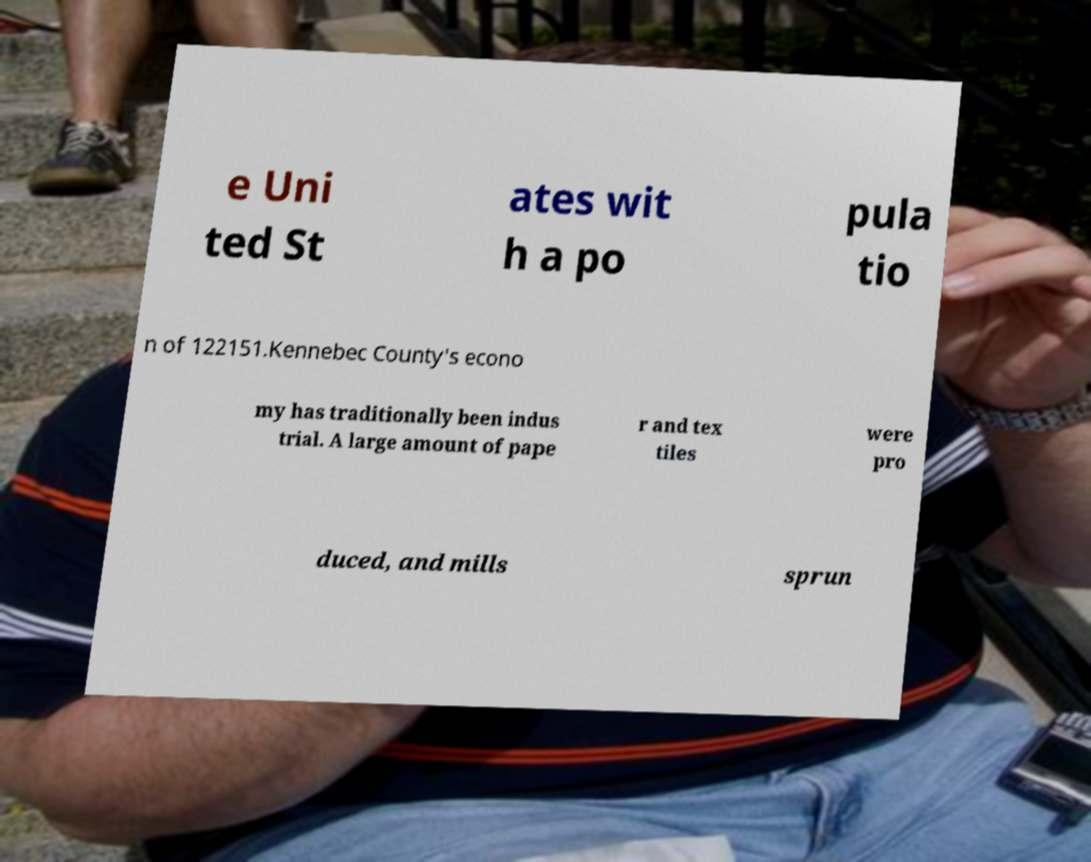Can you accurately transcribe the text from the provided image for me? e Uni ted St ates wit h a po pula tio n of 122151.Kennebec County's econo my has traditionally been indus trial. A large amount of pape r and tex tiles were pro duced, and mills sprun 